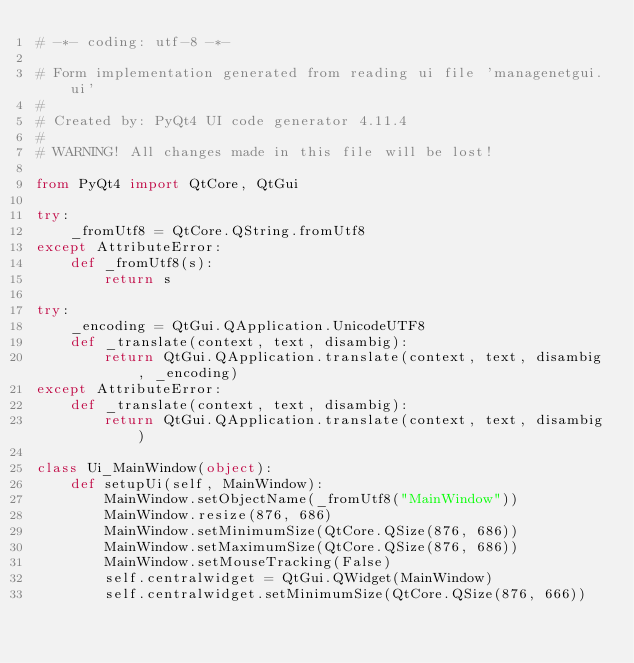Convert code to text. <code><loc_0><loc_0><loc_500><loc_500><_Python_># -*- coding: utf-8 -*-

# Form implementation generated from reading ui file 'managenetgui.ui'
#
# Created by: PyQt4 UI code generator 4.11.4
#
# WARNING! All changes made in this file will be lost!

from PyQt4 import QtCore, QtGui

try:
    _fromUtf8 = QtCore.QString.fromUtf8
except AttributeError:
    def _fromUtf8(s):
        return s

try:
    _encoding = QtGui.QApplication.UnicodeUTF8
    def _translate(context, text, disambig):
        return QtGui.QApplication.translate(context, text, disambig, _encoding)
except AttributeError:
    def _translate(context, text, disambig):
        return QtGui.QApplication.translate(context, text, disambig)

class Ui_MainWindow(object):
    def setupUi(self, MainWindow):
        MainWindow.setObjectName(_fromUtf8("MainWindow"))
        MainWindow.resize(876, 686)
        MainWindow.setMinimumSize(QtCore.QSize(876, 686))
        MainWindow.setMaximumSize(QtCore.QSize(876, 686))
        MainWindow.setMouseTracking(False)
        self.centralwidget = QtGui.QWidget(MainWindow)
        self.centralwidget.setMinimumSize(QtCore.QSize(876, 666))</code> 